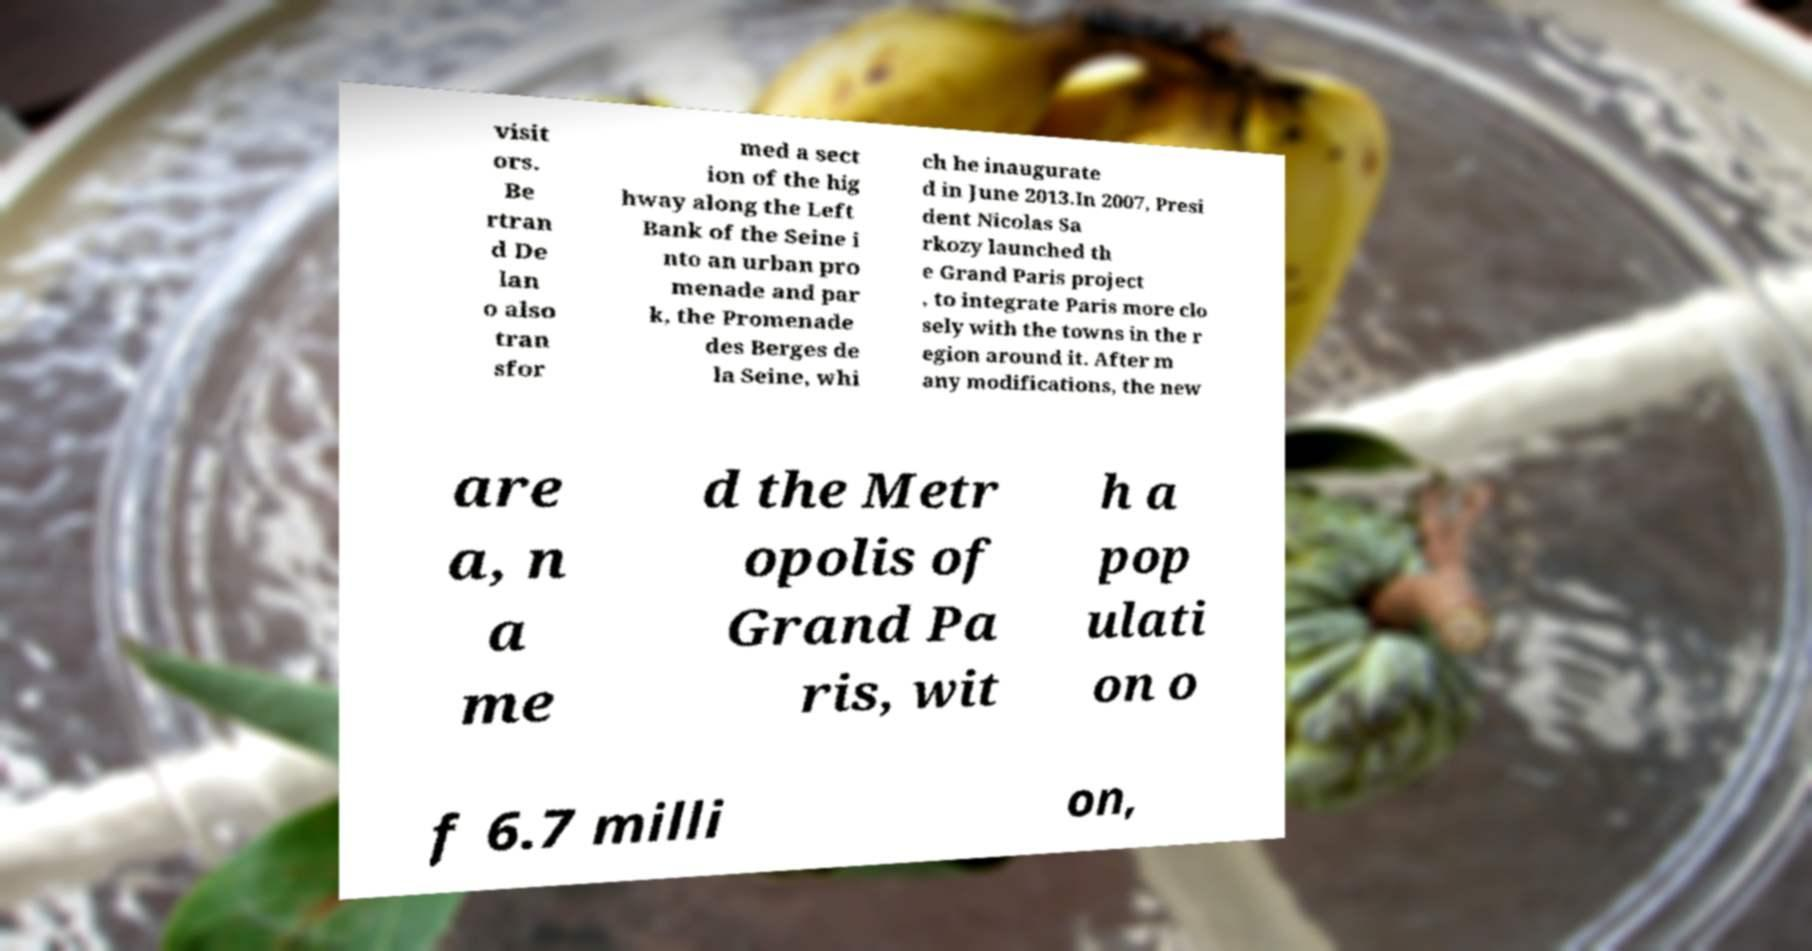Please read and relay the text visible in this image. What does it say? visit ors. Be rtran d De lan o also tran sfor med a sect ion of the hig hway along the Left Bank of the Seine i nto an urban pro menade and par k, the Promenade des Berges de la Seine, whi ch he inaugurate d in June 2013.In 2007, Presi dent Nicolas Sa rkozy launched th e Grand Paris project , to integrate Paris more clo sely with the towns in the r egion around it. After m any modifications, the new are a, n a me d the Metr opolis of Grand Pa ris, wit h a pop ulati on o f 6.7 milli on, 